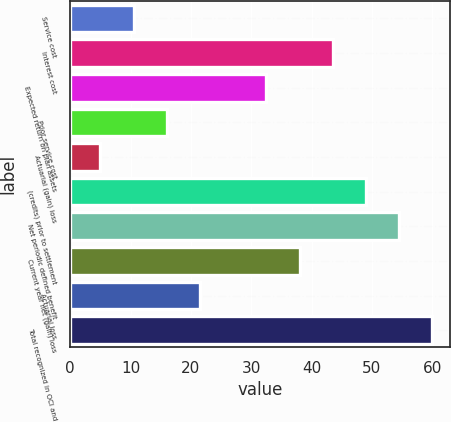<chart> <loc_0><loc_0><loc_500><loc_500><bar_chart><fcel>Service cost<fcel>Interest cost<fcel>Expected return on plan assets<fcel>Prior service cost<fcel>Actuarial (gain) loss<fcel>(credits) prior to settlement<fcel>Net periodic defined benefit<fcel>Current year net (gain) loss<fcel>Actuarial loss<fcel>Total recognized in OCI and<nl><fcel>10.5<fcel>43.5<fcel>32.5<fcel>16<fcel>5<fcel>49<fcel>54.5<fcel>38<fcel>21.5<fcel>60<nl></chart> 